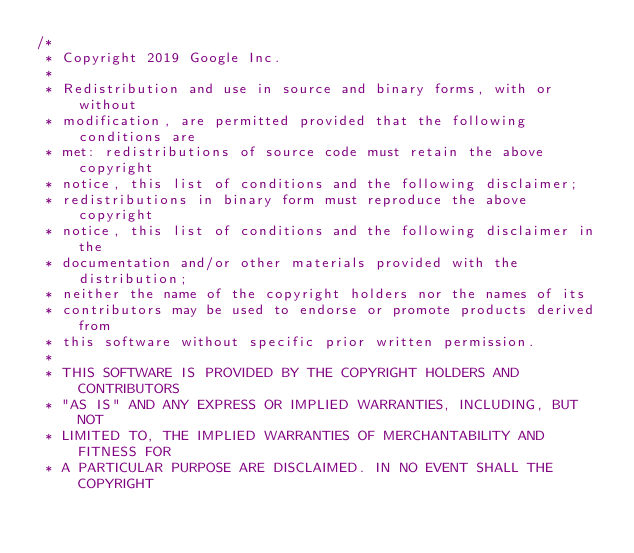Convert code to text. <code><loc_0><loc_0><loc_500><loc_500><_C++_>/*
 * Copyright 2019 Google Inc.
 *
 * Redistribution and use in source and binary forms, with or without
 * modification, are permitted provided that the following conditions are
 * met: redistributions of source code must retain the above copyright
 * notice, this list of conditions and the following disclaimer;
 * redistributions in binary form must reproduce the above copyright
 * notice, this list of conditions and the following disclaimer in the
 * documentation and/or other materials provided with the distribution;
 * neither the name of the copyright holders nor the names of its
 * contributors may be used to endorse or promote products derived from
 * this software without specific prior written permission.
 *
 * THIS SOFTWARE IS PROVIDED BY THE COPYRIGHT HOLDERS AND CONTRIBUTORS
 * "AS IS" AND ANY EXPRESS OR IMPLIED WARRANTIES, INCLUDING, BUT NOT
 * LIMITED TO, THE IMPLIED WARRANTIES OF MERCHANTABILITY AND FITNESS FOR
 * A PARTICULAR PURPOSE ARE DISCLAIMED. IN NO EVENT SHALL THE COPYRIGHT</code> 